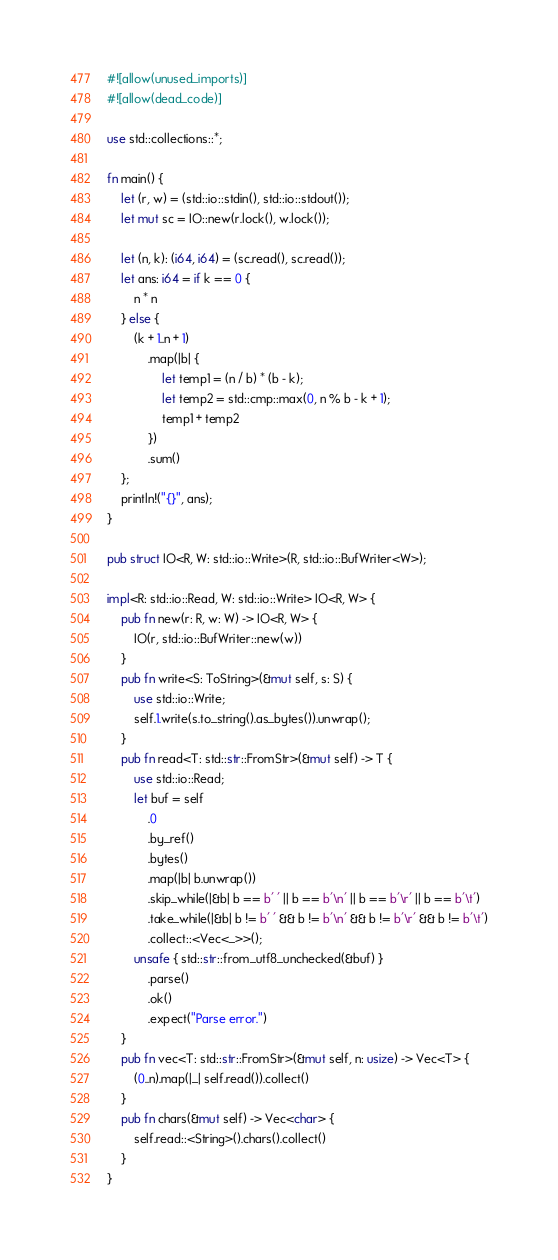Convert code to text. <code><loc_0><loc_0><loc_500><loc_500><_Rust_>#![allow(unused_imports)]
#![allow(dead_code)]

use std::collections::*;

fn main() {
    let (r, w) = (std::io::stdin(), std::io::stdout());
    let mut sc = IO::new(r.lock(), w.lock());

    let (n, k): (i64, i64) = (sc.read(), sc.read());
    let ans: i64 = if k == 0 {
        n * n
    } else {
        (k + 1..n + 1)
            .map(|b| {
                let temp1 = (n / b) * (b - k);
                let temp2 = std::cmp::max(0, n % b - k + 1);
                temp1 + temp2
            })
            .sum()
    };
    println!("{}", ans);
}

pub struct IO<R, W: std::io::Write>(R, std::io::BufWriter<W>);

impl<R: std::io::Read, W: std::io::Write> IO<R, W> {
    pub fn new(r: R, w: W) -> IO<R, W> {
        IO(r, std::io::BufWriter::new(w))
    }
    pub fn write<S: ToString>(&mut self, s: S) {
        use std::io::Write;
        self.1.write(s.to_string().as_bytes()).unwrap();
    }
    pub fn read<T: std::str::FromStr>(&mut self) -> T {
        use std::io::Read;
        let buf = self
            .0
            .by_ref()
            .bytes()
            .map(|b| b.unwrap())
            .skip_while(|&b| b == b' ' || b == b'\n' || b == b'\r' || b == b'\t')
            .take_while(|&b| b != b' ' && b != b'\n' && b != b'\r' && b != b'\t')
            .collect::<Vec<_>>();
        unsafe { std::str::from_utf8_unchecked(&buf) }
            .parse()
            .ok()
            .expect("Parse error.")
    }
    pub fn vec<T: std::str::FromStr>(&mut self, n: usize) -> Vec<T> {
        (0..n).map(|_| self.read()).collect()
    }
    pub fn chars(&mut self) -> Vec<char> {
        self.read::<String>().chars().collect()
    }
}</code> 